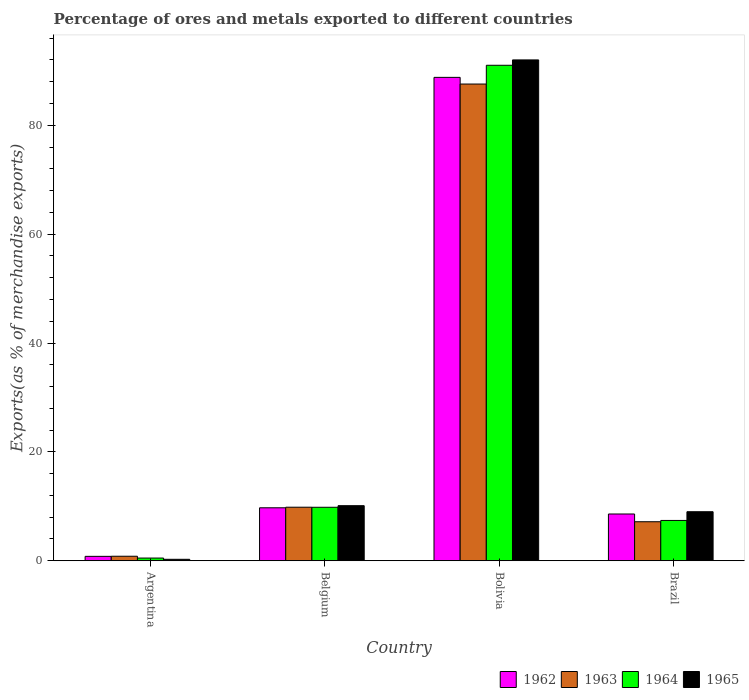Are the number of bars on each tick of the X-axis equal?
Offer a very short reply. Yes. How many bars are there on the 2nd tick from the left?
Offer a very short reply. 4. What is the label of the 4th group of bars from the left?
Ensure brevity in your answer.  Brazil. What is the percentage of exports to different countries in 1964 in Bolivia?
Keep it short and to the point. 91.02. Across all countries, what is the maximum percentage of exports to different countries in 1964?
Give a very brief answer. 91.02. Across all countries, what is the minimum percentage of exports to different countries in 1965?
Your answer should be very brief. 0.27. In which country was the percentage of exports to different countries in 1963 minimum?
Keep it short and to the point. Argentina. What is the total percentage of exports to different countries in 1964 in the graph?
Provide a succinct answer. 108.75. What is the difference between the percentage of exports to different countries in 1964 in Argentina and that in Brazil?
Make the answer very short. -6.91. What is the difference between the percentage of exports to different countries in 1965 in Belgium and the percentage of exports to different countries in 1962 in Brazil?
Your answer should be very brief. 1.53. What is the average percentage of exports to different countries in 1963 per country?
Make the answer very short. 26.35. What is the difference between the percentage of exports to different countries of/in 1964 and percentage of exports to different countries of/in 1962 in Bolivia?
Offer a very short reply. 2.22. What is the ratio of the percentage of exports to different countries in 1963 in Bolivia to that in Brazil?
Keep it short and to the point. 12.21. Is the percentage of exports to different countries in 1962 in Argentina less than that in Belgium?
Provide a short and direct response. Yes. Is the difference between the percentage of exports to different countries in 1964 in Argentina and Belgium greater than the difference between the percentage of exports to different countries in 1962 in Argentina and Belgium?
Make the answer very short. No. What is the difference between the highest and the second highest percentage of exports to different countries in 1964?
Your response must be concise. -81.19. What is the difference between the highest and the lowest percentage of exports to different countries in 1964?
Make the answer very short. 90.52. In how many countries, is the percentage of exports to different countries in 1963 greater than the average percentage of exports to different countries in 1963 taken over all countries?
Offer a very short reply. 1. What does the 2nd bar from the left in Brazil represents?
Your answer should be very brief. 1963. Is it the case that in every country, the sum of the percentage of exports to different countries in 1963 and percentage of exports to different countries in 1962 is greater than the percentage of exports to different countries in 1965?
Your answer should be very brief. Yes. What is the difference between two consecutive major ticks on the Y-axis?
Your answer should be very brief. 20. Are the values on the major ticks of Y-axis written in scientific E-notation?
Your answer should be compact. No. Does the graph contain any zero values?
Your answer should be very brief. No. Does the graph contain grids?
Ensure brevity in your answer.  No. Where does the legend appear in the graph?
Your answer should be compact. Bottom right. How many legend labels are there?
Make the answer very short. 4. What is the title of the graph?
Your answer should be very brief. Percentage of ores and metals exported to different countries. Does "1970" appear as one of the legend labels in the graph?
Provide a succinct answer. No. What is the label or title of the X-axis?
Provide a short and direct response. Country. What is the label or title of the Y-axis?
Provide a short and direct response. Exports(as % of merchandise exports). What is the Exports(as % of merchandise exports) in 1962 in Argentina?
Offer a very short reply. 0.81. What is the Exports(as % of merchandise exports) of 1963 in Argentina?
Provide a succinct answer. 0.83. What is the Exports(as % of merchandise exports) of 1964 in Argentina?
Provide a short and direct response. 0.5. What is the Exports(as % of merchandise exports) in 1965 in Argentina?
Give a very brief answer. 0.27. What is the Exports(as % of merchandise exports) of 1962 in Belgium?
Provide a succinct answer. 9.73. What is the Exports(as % of merchandise exports) in 1963 in Belgium?
Keep it short and to the point. 9.84. What is the Exports(as % of merchandise exports) of 1964 in Belgium?
Offer a very short reply. 9.83. What is the Exports(as % of merchandise exports) of 1965 in Belgium?
Offer a terse response. 10.12. What is the Exports(as % of merchandise exports) of 1962 in Bolivia?
Offer a very short reply. 88.79. What is the Exports(as % of merchandise exports) of 1963 in Bolivia?
Your response must be concise. 87.57. What is the Exports(as % of merchandise exports) of 1964 in Bolivia?
Offer a terse response. 91.02. What is the Exports(as % of merchandise exports) of 1965 in Bolivia?
Your response must be concise. 92. What is the Exports(as % of merchandise exports) in 1962 in Brazil?
Offer a terse response. 8.59. What is the Exports(as % of merchandise exports) in 1963 in Brazil?
Your response must be concise. 7.17. What is the Exports(as % of merchandise exports) in 1964 in Brazil?
Keep it short and to the point. 7.41. What is the Exports(as % of merchandise exports) in 1965 in Brazil?
Provide a short and direct response. 9.01. Across all countries, what is the maximum Exports(as % of merchandise exports) of 1962?
Your answer should be very brief. 88.79. Across all countries, what is the maximum Exports(as % of merchandise exports) of 1963?
Keep it short and to the point. 87.57. Across all countries, what is the maximum Exports(as % of merchandise exports) of 1964?
Offer a terse response. 91.02. Across all countries, what is the maximum Exports(as % of merchandise exports) of 1965?
Offer a very short reply. 92. Across all countries, what is the minimum Exports(as % of merchandise exports) in 1962?
Your response must be concise. 0.81. Across all countries, what is the minimum Exports(as % of merchandise exports) of 1963?
Keep it short and to the point. 0.83. Across all countries, what is the minimum Exports(as % of merchandise exports) in 1964?
Your answer should be compact. 0.5. Across all countries, what is the minimum Exports(as % of merchandise exports) of 1965?
Ensure brevity in your answer.  0.27. What is the total Exports(as % of merchandise exports) in 1962 in the graph?
Your response must be concise. 107.93. What is the total Exports(as % of merchandise exports) in 1963 in the graph?
Ensure brevity in your answer.  105.41. What is the total Exports(as % of merchandise exports) of 1964 in the graph?
Make the answer very short. 108.75. What is the total Exports(as % of merchandise exports) in 1965 in the graph?
Give a very brief answer. 111.4. What is the difference between the Exports(as % of merchandise exports) in 1962 in Argentina and that in Belgium?
Make the answer very short. -8.92. What is the difference between the Exports(as % of merchandise exports) in 1963 in Argentina and that in Belgium?
Your answer should be compact. -9. What is the difference between the Exports(as % of merchandise exports) in 1964 in Argentina and that in Belgium?
Keep it short and to the point. -9.33. What is the difference between the Exports(as % of merchandise exports) of 1965 in Argentina and that in Belgium?
Keep it short and to the point. -9.85. What is the difference between the Exports(as % of merchandise exports) in 1962 in Argentina and that in Bolivia?
Your answer should be very brief. -87.98. What is the difference between the Exports(as % of merchandise exports) in 1963 in Argentina and that in Bolivia?
Ensure brevity in your answer.  -86.74. What is the difference between the Exports(as % of merchandise exports) in 1964 in Argentina and that in Bolivia?
Offer a very short reply. -90.52. What is the difference between the Exports(as % of merchandise exports) of 1965 in Argentina and that in Bolivia?
Provide a short and direct response. -91.73. What is the difference between the Exports(as % of merchandise exports) of 1962 in Argentina and that in Brazil?
Your response must be concise. -7.78. What is the difference between the Exports(as % of merchandise exports) of 1963 in Argentina and that in Brazil?
Keep it short and to the point. -6.34. What is the difference between the Exports(as % of merchandise exports) in 1964 in Argentina and that in Brazil?
Your answer should be compact. -6.91. What is the difference between the Exports(as % of merchandise exports) in 1965 in Argentina and that in Brazil?
Offer a very short reply. -8.74. What is the difference between the Exports(as % of merchandise exports) of 1962 in Belgium and that in Bolivia?
Make the answer very short. -79.06. What is the difference between the Exports(as % of merchandise exports) in 1963 in Belgium and that in Bolivia?
Make the answer very short. -77.73. What is the difference between the Exports(as % of merchandise exports) of 1964 in Belgium and that in Bolivia?
Your answer should be very brief. -81.19. What is the difference between the Exports(as % of merchandise exports) in 1965 in Belgium and that in Bolivia?
Provide a short and direct response. -81.88. What is the difference between the Exports(as % of merchandise exports) of 1962 in Belgium and that in Brazil?
Provide a short and direct response. 1.14. What is the difference between the Exports(as % of merchandise exports) in 1963 in Belgium and that in Brazil?
Provide a succinct answer. 2.67. What is the difference between the Exports(as % of merchandise exports) of 1964 in Belgium and that in Brazil?
Make the answer very short. 2.42. What is the difference between the Exports(as % of merchandise exports) in 1965 in Belgium and that in Brazil?
Your response must be concise. 1.11. What is the difference between the Exports(as % of merchandise exports) of 1962 in Bolivia and that in Brazil?
Offer a very short reply. 80.2. What is the difference between the Exports(as % of merchandise exports) of 1963 in Bolivia and that in Brazil?
Your answer should be compact. 80.4. What is the difference between the Exports(as % of merchandise exports) of 1964 in Bolivia and that in Brazil?
Offer a terse response. 83.61. What is the difference between the Exports(as % of merchandise exports) of 1965 in Bolivia and that in Brazil?
Ensure brevity in your answer.  82.99. What is the difference between the Exports(as % of merchandise exports) of 1962 in Argentina and the Exports(as % of merchandise exports) of 1963 in Belgium?
Offer a very short reply. -9.02. What is the difference between the Exports(as % of merchandise exports) in 1962 in Argentina and the Exports(as % of merchandise exports) in 1964 in Belgium?
Offer a very short reply. -9.01. What is the difference between the Exports(as % of merchandise exports) of 1962 in Argentina and the Exports(as % of merchandise exports) of 1965 in Belgium?
Offer a very short reply. -9.31. What is the difference between the Exports(as % of merchandise exports) of 1963 in Argentina and the Exports(as % of merchandise exports) of 1964 in Belgium?
Ensure brevity in your answer.  -8.99. What is the difference between the Exports(as % of merchandise exports) in 1963 in Argentina and the Exports(as % of merchandise exports) in 1965 in Belgium?
Give a very brief answer. -9.29. What is the difference between the Exports(as % of merchandise exports) of 1964 in Argentina and the Exports(as % of merchandise exports) of 1965 in Belgium?
Offer a terse response. -9.62. What is the difference between the Exports(as % of merchandise exports) of 1962 in Argentina and the Exports(as % of merchandise exports) of 1963 in Bolivia?
Your answer should be very brief. -86.76. What is the difference between the Exports(as % of merchandise exports) of 1962 in Argentina and the Exports(as % of merchandise exports) of 1964 in Bolivia?
Provide a succinct answer. -90.2. What is the difference between the Exports(as % of merchandise exports) of 1962 in Argentina and the Exports(as % of merchandise exports) of 1965 in Bolivia?
Your answer should be compact. -91.19. What is the difference between the Exports(as % of merchandise exports) of 1963 in Argentina and the Exports(as % of merchandise exports) of 1964 in Bolivia?
Your answer should be compact. -90.18. What is the difference between the Exports(as % of merchandise exports) of 1963 in Argentina and the Exports(as % of merchandise exports) of 1965 in Bolivia?
Provide a short and direct response. -91.17. What is the difference between the Exports(as % of merchandise exports) in 1964 in Argentina and the Exports(as % of merchandise exports) in 1965 in Bolivia?
Offer a terse response. -91.5. What is the difference between the Exports(as % of merchandise exports) in 1962 in Argentina and the Exports(as % of merchandise exports) in 1963 in Brazil?
Make the answer very short. -6.36. What is the difference between the Exports(as % of merchandise exports) of 1962 in Argentina and the Exports(as % of merchandise exports) of 1964 in Brazil?
Offer a very short reply. -6.59. What is the difference between the Exports(as % of merchandise exports) of 1962 in Argentina and the Exports(as % of merchandise exports) of 1965 in Brazil?
Your response must be concise. -8.2. What is the difference between the Exports(as % of merchandise exports) of 1963 in Argentina and the Exports(as % of merchandise exports) of 1964 in Brazil?
Your answer should be compact. -6.57. What is the difference between the Exports(as % of merchandise exports) in 1963 in Argentina and the Exports(as % of merchandise exports) in 1965 in Brazil?
Keep it short and to the point. -8.18. What is the difference between the Exports(as % of merchandise exports) in 1964 in Argentina and the Exports(as % of merchandise exports) in 1965 in Brazil?
Ensure brevity in your answer.  -8.51. What is the difference between the Exports(as % of merchandise exports) in 1962 in Belgium and the Exports(as % of merchandise exports) in 1963 in Bolivia?
Provide a short and direct response. -77.84. What is the difference between the Exports(as % of merchandise exports) in 1962 in Belgium and the Exports(as % of merchandise exports) in 1964 in Bolivia?
Offer a terse response. -81.28. What is the difference between the Exports(as % of merchandise exports) in 1962 in Belgium and the Exports(as % of merchandise exports) in 1965 in Bolivia?
Provide a short and direct response. -82.27. What is the difference between the Exports(as % of merchandise exports) in 1963 in Belgium and the Exports(as % of merchandise exports) in 1964 in Bolivia?
Keep it short and to the point. -81.18. What is the difference between the Exports(as % of merchandise exports) in 1963 in Belgium and the Exports(as % of merchandise exports) in 1965 in Bolivia?
Your response must be concise. -82.16. What is the difference between the Exports(as % of merchandise exports) in 1964 in Belgium and the Exports(as % of merchandise exports) in 1965 in Bolivia?
Your answer should be compact. -82.17. What is the difference between the Exports(as % of merchandise exports) of 1962 in Belgium and the Exports(as % of merchandise exports) of 1963 in Brazil?
Your response must be concise. 2.56. What is the difference between the Exports(as % of merchandise exports) in 1962 in Belgium and the Exports(as % of merchandise exports) in 1964 in Brazil?
Ensure brevity in your answer.  2.33. What is the difference between the Exports(as % of merchandise exports) in 1962 in Belgium and the Exports(as % of merchandise exports) in 1965 in Brazil?
Provide a succinct answer. 0.72. What is the difference between the Exports(as % of merchandise exports) of 1963 in Belgium and the Exports(as % of merchandise exports) of 1964 in Brazil?
Your answer should be very brief. 2.43. What is the difference between the Exports(as % of merchandise exports) of 1963 in Belgium and the Exports(as % of merchandise exports) of 1965 in Brazil?
Offer a terse response. 0.83. What is the difference between the Exports(as % of merchandise exports) in 1964 in Belgium and the Exports(as % of merchandise exports) in 1965 in Brazil?
Keep it short and to the point. 0.82. What is the difference between the Exports(as % of merchandise exports) of 1962 in Bolivia and the Exports(as % of merchandise exports) of 1963 in Brazil?
Your answer should be compact. 81.62. What is the difference between the Exports(as % of merchandise exports) in 1962 in Bolivia and the Exports(as % of merchandise exports) in 1964 in Brazil?
Your answer should be very brief. 81.39. What is the difference between the Exports(as % of merchandise exports) of 1962 in Bolivia and the Exports(as % of merchandise exports) of 1965 in Brazil?
Your answer should be compact. 79.78. What is the difference between the Exports(as % of merchandise exports) in 1963 in Bolivia and the Exports(as % of merchandise exports) in 1964 in Brazil?
Make the answer very short. 80.16. What is the difference between the Exports(as % of merchandise exports) in 1963 in Bolivia and the Exports(as % of merchandise exports) in 1965 in Brazil?
Your answer should be very brief. 78.56. What is the difference between the Exports(as % of merchandise exports) in 1964 in Bolivia and the Exports(as % of merchandise exports) in 1965 in Brazil?
Your response must be concise. 82.01. What is the average Exports(as % of merchandise exports) of 1962 per country?
Provide a short and direct response. 26.98. What is the average Exports(as % of merchandise exports) in 1963 per country?
Your answer should be compact. 26.35. What is the average Exports(as % of merchandise exports) of 1964 per country?
Make the answer very short. 27.19. What is the average Exports(as % of merchandise exports) in 1965 per country?
Keep it short and to the point. 27.85. What is the difference between the Exports(as % of merchandise exports) in 1962 and Exports(as % of merchandise exports) in 1963 in Argentina?
Give a very brief answer. -0.02. What is the difference between the Exports(as % of merchandise exports) of 1962 and Exports(as % of merchandise exports) of 1964 in Argentina?
Offer a terse response. 0.31. What is the difference between the Exports(as % of merchandise exports) of 1962 and Exports(as % of merchandise exports) of 1965 in Argentina?
Your answer should be very brief. 0.54. What is the difference between the Exports(as % of merchandise exports) of 1963 and Exports(as % of merchandise exports) of 1964 in Argentina?
Offer a very short reply. 0.33. What is the difference between the Exports(as % of merchandise exports) in 1963 and Exports(as % of merchandise exports) in 1965 in Argentina?
Give a very brief answer. 0.56. What is the difference between the Exports(as % of merchandise exports) of 1964 and Exports(as % of merchandise exports) of 1965 in Argentina?
Your answer should be compact. 0.23. What is the difference between the Exports(as % of merchandise exports) in 1962 and Exports(as % of merchandise exports) in 1963 in Belgium?
Make the answer very short. -0.1. What is the difference between the Exports(as % of merchandise exports) in 1962 and Exports(as % of merchandise exports) in 1964 in Belgium?
Ensure brevity in your answer.  -0.09. What is the difference between the Exports(as % of merchandise exports) of 1962 and Exports(as % of merchandise exports) of 1965 in Belgium?
Give a very brief answer. -0.39. What is the difference between the Exports(as % of merchandise exports) in 1963 and Exports(as % of merchandise exports) in 1964 in Belgium?
Give a very brief answer. 0.01. What is the difference between the Exports(as % of merchandise exports) of 1963 and Exports(as % of merchandise exports) of 1965 in Belgium?
Your response must be concise. -0.28. What is the difference between the Exports(as % of merchandise exports) in 1964 and Exports(as % of merchandise exports) in 1965 in Belgium?
Provide a short and direct response. -0.29. What is the difference between the Exports(as % of merchandise exports) in 1962 and Exports(as % of merchandise exports) in 1963 in Bolivia?
Your answer should be compact. 1.22. What is the difference between the Exports(as % of merchandise exports) of 1962 and Exports(as % of merchandise exports) of 1964 in Bolivia?
Your answer should be compact. -2.22. What is the difference between the Exports(as % of merchandise exports) of 1962 and Exports(as % of merchandise exports) of 1965 in Bolivia?
Offer a terse response. -3.21. What is the difference between the Exports(as % of merchandise exports) in 1963 and Exports(as % of merchandise exports) in 1964 in Bolivia?
Provide a succinct answer. -3.45. What is the difference between the Exports(as % of merchandise exports) of 1963 and Exports(as % of merchandise exports) of 1965 in Bolivia?
Give a very brief answer. -4.43. What is the difference between the Exports(as % of merchandise exports) of 1964 and Exports(as % of merchandise exports) of 1965 in Bolivia?
Provide a short and direct response. -0.98. What is the difference between the Exports(as % of merchandise exports) in 1962 and Exports(as % of merchandise exports) in 1963 in Brazil?
Your answer should be compact. 1.42. What is the difference between the Exports(as % of merchandise exports) of 1962 and Exports(as % of merchandise exports) of 1964 in Brazil?
Your answer should be very brief. 1.18. What is the difference between the Exports(as % of merchandise exports) of 1962 and Exports(as % of merchandise exports) of 1965 in Brazil?
Keep it short and to the point. -0.42. What is the difference between the Exports(as % of merchandise exports) of 1963 and Exports(as % of merchandise exports) of 1964 in Brazil?
Ensure brevity in your answer.  -0.24. What is the difference between the Exports(as % of merchandise exports) of 1963 and Exports(as % of merchandise exports) of 1965 in Brazil?
Your answer should be compact. -1.84. What is the difference between the Exports(as % of merchandise exports) in 1964 and Exports(as % of merchandise exports) in 1965 in Brazil?
Make the answer very short. -1.6. What is the ratio of the Exports(as % of merchandise exports) in 1962 in Argentina to that in Belgium?
Offer a very short reply. 0.08. What is the ratio of the Exports(as % of merchandise exports) of 1963 in Argentina to that in Belgium?
Your response must be concise. 0.08. What is the ratio of the Exports(as % of merchandise exports) of 1964 in Argentina to that in Belgium?
Provide a succinct answer. 0.05. What is the ratio of the Exports(as % of merchandise exports) in 1965 in Argentina to that in Belgium?
Keep it short and to the point. 0.03. What is the ratio of the Exports(as % of merchandise exports) of 1962 in Argentina to that in Bolivia?
Offer a very short reply. 0.01. What is the ratio of the Exports(as % of merchandise exports) in 1963 in Argentina to that in Bolivia?
Make the answer very short. 0.01. What is the ratio of the Exports(as % of merchandise exports) of 1964 in Argentina to that in Bolivia?
Offer a very short reply. 0.01. What is the ratio of the Exports(as % of merchandise exports) in 1965 in Argentina to that in Bolivia?
Your response must be concise. 0. What is the ratio of the Exports(as % of merchandise exports) of 1962 in Argentina to that in Brazil?
Give a very brief answer. 0.09. What is the ratio of the Exports(as % of merchandise exports) of 1963 in Argentina to that in Brazil?
Your answer should be compact. 0.12. What is the ratio of the Exports(as % of merchandise exports) of 1964 in Argentina to that in Brazil?
Provide a succinct answer. 0.07. What is the ratio of the Exports(as % of merchandise exports) of 1965 in Argentina to that in Brazil?
Provide a succinct answer. 0.03. What is the ratio of the Exports(as % of merchandise exports) in 1962 in Belgium to that in Bolivia?
Make the answer very short. 0.11. What is the ratio of the Exports(as % of merchandise exports) of 1963 in Belgium to that in Bolivia?
Your answer should be compact. 0.11. What is the ratio of the Exports(as % of merchandise exports) in 1964 in Belgium to that in Bolivia?
Keep it short and to the point. 0.11. What is the ratio of the Exports(as % of merchandise exports) of 1965 in Belgium to that in Bolivia?
Your response must be concise. 0.11. What is the ratio of the Exports(as % of merchandise exports) in 1962 in Belgium to that in Brazil?
Offer a very short reply. 1.13. What is the ratio of the Exports(as % of merchandise exports) of 1963 in Belgium to that in Brazil?
Provide a succinct answer. 1.37. What is the ratio of the Exports(as % of merchandise exports) in 1964 in Belgium to that in Brazil?
Your answer should be very brief. 1.33. What is the ratio of the Exports(as % of merchandise exports) in 1965 in Belgium to that in Brazil?
Ensure brevity in your answer.  1.12. What is the ratio of the Exports(as % of merchandise exports) in 1962 in Bolivia to that in Brazil?
Your answer should be compact. 10.33. What is the ratio of the Exports(as % of merchandise exports) of 1963 in Bolivia to that in Brazil?
Offer a very short reply. 12.21. What is the ratio of the Exports(as % of merchandise exports) of 1964 in Bolivia to that in Brazil?
Keep it short and to the point. 12.29. What is the ratio of the Exports(as % of merchandise exports) of 1965 in Bolivia to that in Brazil?
Keep it short and to the point. 10.21. What is the difference between the highest and the second highest Exports(as % of merchandise exports) in 1962?
Make the answer very short. 79.06. What is the difference between the highest and the second highest Exports(as % of merchandise exports) in 1963?
Keep it short and to the point. 77.73. What is the difference between the highest and the second highest Exports(as % of merchandise exports) in 1964?
Your answer should be very brief. 81.19. What is the difference between the highest and the second highest Exports(as % of merchandise exports) of 1965?
Offer a terse response. 81.88. What is the difference between the highest and the lowest Exports(as % of merchandise exports) of 1962?
Your answer should be compact. 87.98. What is the difference between the highest and the lowest Exports(as % of merchandise exports) of 1963?
Your answer should be compact. 86.74. What is the difference between the highest and the lowest Exports(as % of merchandise exports) in 1964?
Keep it short and to the point. 90.52. What is the difference between the highest and the lowest Exports(as % of merchandise exports) in 1965?
Provide a short and direct response. 91.73. 